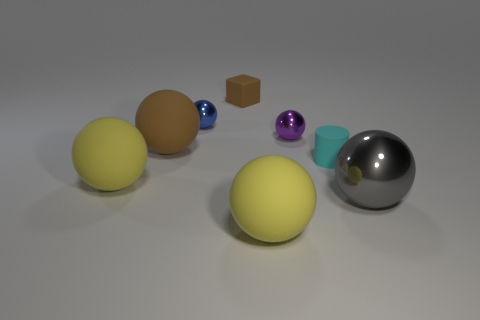There is a yellow rubber object in front of the big gray sphere; does it have the same shape as the brown rubber thing in front of the small purple metal thing?
Give a very brief answer. Yes. Are the big yellow object that is behind the big shiny thing and the object that is right of the cylinder made of the same material?
Your response must be concise. No. What material is the brown thing behind the large brown rubber object that is in front of the purple shiny ball?
Keep it short and to the point. Rubber. What shape is the yellow matte thing behind the matte ball that is in front of the big sphere on the right side of the cyan cylinder?
Offer a very short reply. Sphere. There is another tiny thing that is the same shape as the tiny blue object; what material is it?
Make the answer very short. Metal. What number of matte cylinders are there?
Offer a terse response. 1. The thing in front of the large gray ball has what shape?
Ensure brevity in your answer.  Sphere. The tiny rubber thing on the left side of the big rubber thing that is in front of the big yellow matte thing that is to the left of the brown rubber sphere is what color?
Provide a short and direct response. Brown. There is a large brown object that is made of the same material as the tiny cylinder; what is its shape?
Your response must be concise. Sphere. Is the number of large brown rubber cylinders less than the number of blue spheres?
Your response must be concise. Yes. 